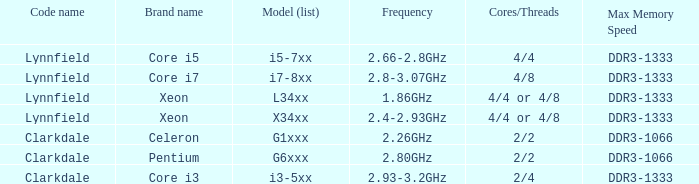2ghz? DDR3-1333. 